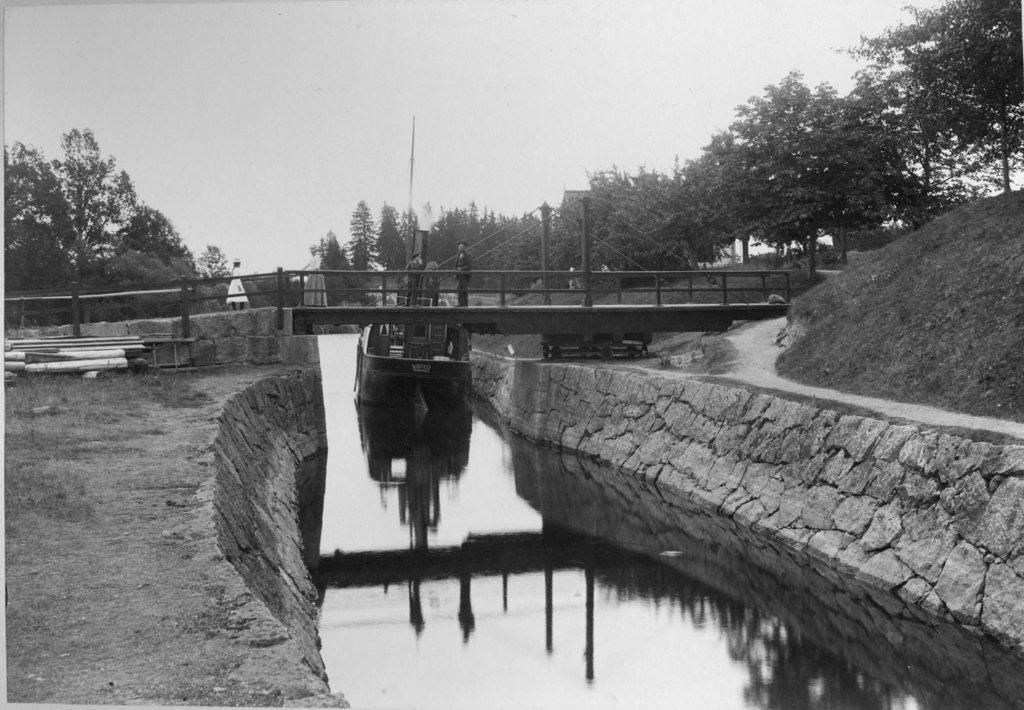Please provide a concise description of this image. There is a river at the bottom of this image. There is a bridge in the middle of this image,There are some persons standing on to this bridge. There are some trees in the background. The sky is at the top of the image. 